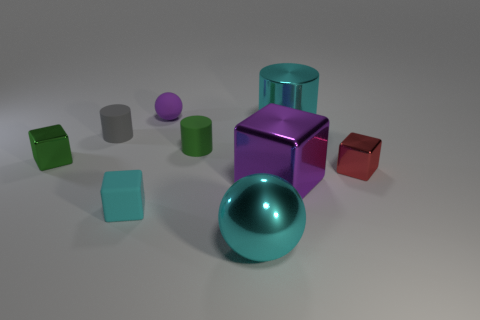Add 1 small purple matte spheres. How many objects exist? 10 Subtract all cubes. How many objects are left? 5 Subtract all small green cylinders. Subtract all cyan blocks. How many objects are left? 7 Add 3 purple metallic blocks. How many purple metallic blocks are left? 4 Add 3 tiny green objects. How many tiny green objects exist? 5 Subtract 0 brown balls. How many objects are left? 9 